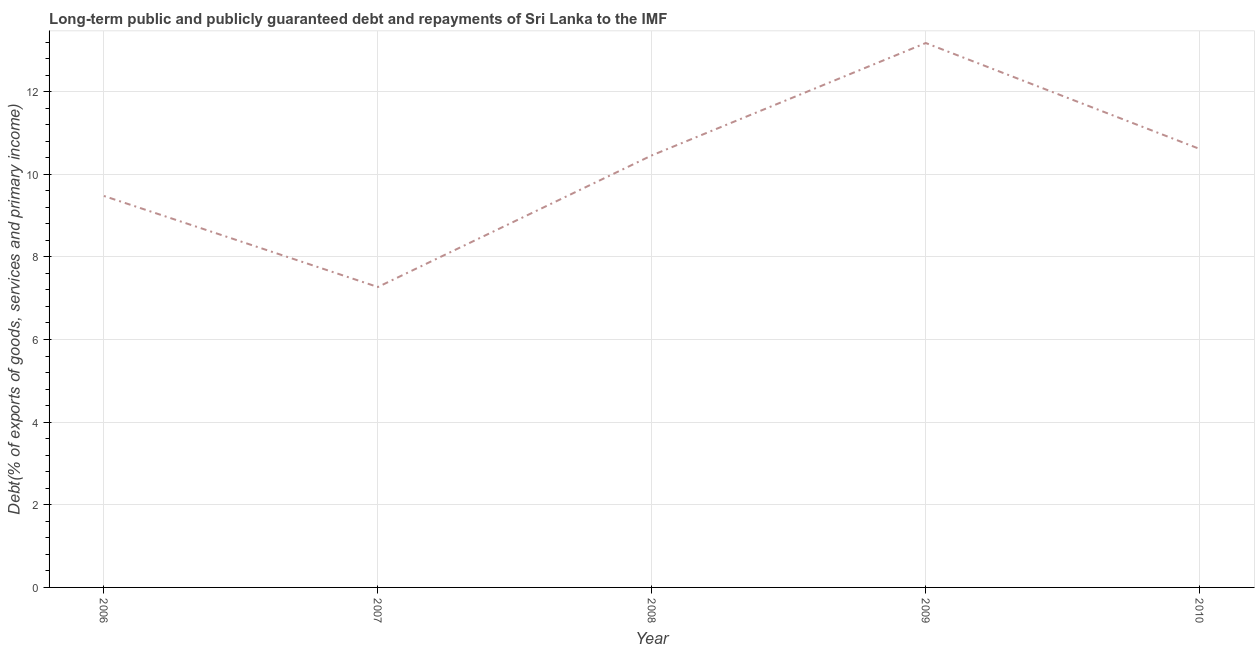What is the debt service in 2010?
Your answer should be compact. 10.61. Across all years, what is the maximum debt service?
Your response must be concise. 13.18. Across all years, what is the minimum debt service?
Ensure brevity in your answer.  7.27. In which year was the debt service maximum?
Provide a succinct answer. 2009. What is the sum of the debt service?
Keep it short and to the point. 50.99. What is the difference between the debt service in 2006 and 2009?
Your answer should be compact. -3.7. What is the average debt service per year?
Keep it short and to the point. 10.2. What is the median debt service?
Offer a terse response. 10.46. Do a majority of the years between 2009 and 2006 (inclusive) have debt service greater than 8.4 %?
Keep it short and to the point. Yes. What is the ratio of the debt service in 2007 to that in 2008?
Your answer should be compact. 0.7. Is the debt service in 2007 less than that in 2010?
Keep it short and to the point. Yes. Is the difference between the debt service in 2007 and 2010 greater than the difference between any two years?
Offer a very short reply. No. What is the difference between the highest and the second highest debt service?
Provide a succinct answer. 2.56. Is the sum of the debt service in 2007 and 2009 greater than the maximum debt service across all years?
Ensure brevity in your answer.  Yes. What is the difference between the highest and the lowest debt service?
Give a very brief answer. 5.91. In how many years, is the debt service greater than the average debt service taken over all years?
Offer a very short reply. 3. How many lines are there?
Your response must be concise. 1. What is the difference between two consecutive major ticks on the Y-axis?
Provide a short and direct response. 2. Are the values on the major ticks of Y-axis written in scientific E-notation?
Your answer should be compact. No. What is the title of the graph?
Offer a very short reply. Long-term public and publicly guaranteed debt and repayments of Sri Lanka to the IMF. What is the label or title of the X-axis?
Your answer should be compact. Year. What is the label or title of the Y-axis?
Offer a terse response. Debt(% of exports of goods, services and primary income). What is the Debt(% of exports of goods, services and primary income) of 2006?
Your response must be concise. 9.47. What is the Debt(% of exports of goods, services and primary income) in 2007?
Your response must be concise. 7.27. What is the Debt(% of exports of goods, services and primary income) in 2008?
Provide a short and direct response. 10.46. What is the Debt(% of exports of goods, services and primary income) of 2009?
Give a very brief answer. 13.18. What is the Debt(% of exports of goods, services and primary income) in 2010?
Make the answer very short. 10.61. What is the difference between the Debt(% of exports of goods, services and primary income) in 2006 and 2007?
Your answer should be compact. 2.2. What is the difference between the Debt(% of exports of goods, services and primary income) in 2006 and 2008?
Ensure brevity in your answer.  -0.98. What is the difference between the Debt(% of exports of goods, services and primary income) in 2006 and 2009?
Ensure brevity in your answer.  -3.7. What is the difference between the Debt(% of exports of goods, services and primary income) in 2006 and 2010?
Give a very brief answer. -1.14. What is the difference between the Debt(% of exports of goods, services and primary income) in 2007 and 2008?
Your answer should be compact. -3.19. What is the difference between the Debt(% of exports of goods, services and primary income) in 2007 and 2009?
Your answer should be compact. -5.91. What is the difference between the Debt(% of exports of goods, services and primary income) in 2007 and 2010?
Make the answer very short. -3.34. What is the difference between the Debt(% of exports of goods, services and primary income) in 2008 and 2009?
Keep it short and to the point. -2.72. What is the difference between the Debt(% of exports of goods, services and primary income) in 2008 and 2010?
Your answer should be very brief. -0.16. What is the difference between the Debt(% of exports of goods, services and primary income) in 2009 and 2010?
Ensure brevity in your answer.  2.56. What is the ratio of the Debt(% of exports of goods, services and primary income) in 2006 to that in 2007?
Offer a very short reply. 1.3. What is the ratio of the Debt(% of exports of goods, services and primary income) in 2006 to that in 2008?
Offer a very short reply. 0.91. What is the ratio of the Debt(% of exports of goods, services and primary income) in 2006 to that in 2009?
Offer a very short reply. 0.72. What is the ratio of the Debt(% of exports of goods, services and primary income) in 2006 to that in 2010?
Offer a very short reply. 0.89. What is the ratio of the Debt(% of exports of goods, services and primary income) in 2007 to that in 2008?
Your answer should be compact. 0.69. What is the ratio of the Debt(% of exports of goods, services and primary income) in 2007 to that in 2009?
Keep it short and to the point. 0.55. What is the ratio of the Debt(% of exports of goods, services and primary income) in 2007 to that in 2010?
Your answer should be very brief. 0.69. What is the ratio of the Debt(% of exports of goods, services and primary income) in 2008 to that in 2009?
Give a very brief answer. 0.79. What is the ratio of the Debt(% of exports of goods, services and primary income) in 2008 to that in 2010?
Give a very brief answer. 0.98. What is the ratio of the Debt(% of exports of goods, services and primary income) in 2009 to that in 2010?
Your response must be concise. 1.24. 